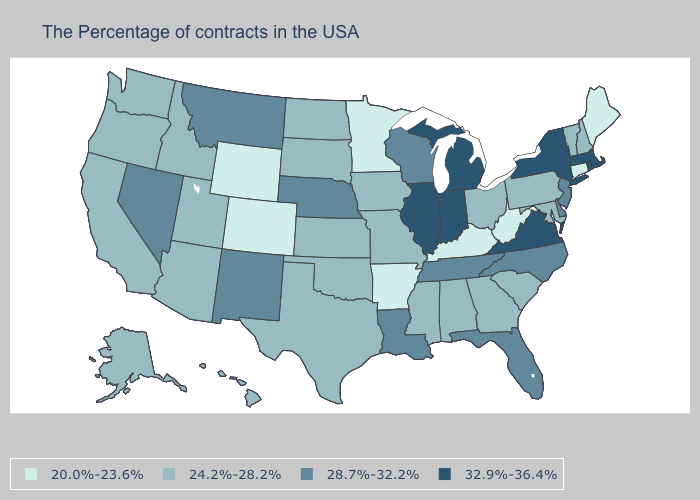Which states hav the highest value in the South?
Concise answer only. Virginia. Which states have the lowest value in the USA?
Short answer required. Maine, Connecticut, West Virginia, Kentucky, Arkansas, Minnesota, Wyoming, Colorado. Name the states that have a value in the range 28.7%-32.2%?
Keep it brief. New Jersey, Delaware, North Carolina, Florida, Tennessee, Wisconsin, Louisiana, Nebraska, New Mexico, Montana, Nevada. What is the value of Connecticut?
Quick response, please. 20.0%-23.6%. What is the value of Iowa?
Be succinct. 24.2%-28.2%. Does the map have missing data?
Keep it brief. No. Does the first symbol in the legend represent the smallest category?
Answer briefly. Yes. Does West Virginia have the lowest value in the USA?
Keep it brief. Yes. What is the value of Hawaii?
Concise answer only. 24.2%-28.2%. Is the legend a continuous bar?
Answer briefly. No. What is the highest value in the MidWest ?
Short answer required. 32.9%-36.4%. Name the states that have a value in the range 32.9%-36.4%?
Write a very short answer. Massachusetts, Rhode Island, New York, Virginia, Michigan, Indiana, Illinois. Name the states that have a value in the range 24.2%-28.2%?
Keep it brief. New Hampshire, Vermont, Maryland, Pennsylvania, South Carolina, Ohio, Georgia, Alabama, Mississippi, Missouri, Iowa, Kansas, Oklahoma, Texas, South Dakota, North Dakota, Utah, Arizona, Idaho, California, Washington, Oregon, Alaska, Hawaii. Does Georgia have the lowest value in the USA?
Quick response, please. No. 